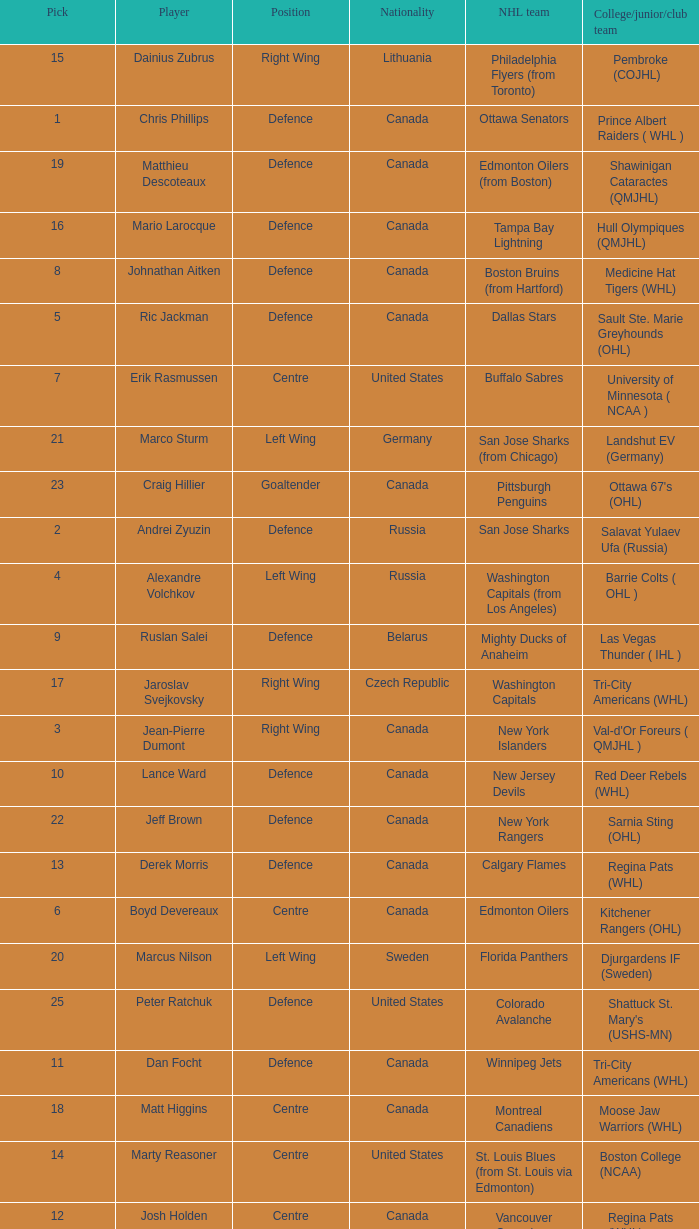Could you parse the entire table? {'header': ['Pick', 'Player', 'Position', 'Nationality', 'NHL team', 'College/junior/club team'], 'rows': [['15', 'Dainius Zubrus', 'Right Wing', 'Lithuania', 'Philadelphia Flyers (from Toronto)', 'Pembroke (COJHL)'], ['1', 'Chris Phillips', 'Defence', 'Canada', 'Ottawa Senators', 'Prince Albert Raiders ( WHL )'], ['19', 'Matthieu Descoteaux', 'Defence', 'Canada', 'Edmonton Oilers (from Boston)', 'Shawinigan Cataractes (QMJHL)'], ['16', 'Mario Larocque', 'Defence', 'Canada', 'Tampa Bay Lightning', 'Hull Olympiques (QMJHL)'], ['8', 'Johnathan Aitken', 'Defence', 'Canada', 'Boston Bruins (from Hartford)', 'Medicine Hat Tigers (WHL)'], ['5', 'Ric Jackman', 'Defence', 'Canada', 'Dallas Stars', 'Sault Ste. Marie Greyhounds (OHL)'], ['7', 'Erik Rasmussen', 'Centre', 'United States', 'Buffalo Sabres', 'University of Minnesota ( NCAA )'], ['21', 'Marco Sturm', 'Left Wing', 'Germany', 'San Jose Sharks (from Chicago)', 'Landshut EV (Germany)'], ['23', 'Craig Hillier', 'Goaltender', 'Canada', 'Pittsburgh Penguins', "Ottawa 67's (OHL)"], ['2', 'Andrei Zyuzin', 'Defence', 'Russia', 'San Jose Sharks', 'Salavat Yulaev Ufa (Russia)'], ['4', 'Alexandre Volchkov', 'Left Wing', 'Russia', 'Washington Capitals (from Los Angeles)', 'Barrie Colts ( OHL )'], ['9', 'Ruslan Salei', 'Defence', 'Belarus', 'Mighty Ducks of Anaheim', 'Las Vegas Thunder ( IHL )'], ['17', 'Jaroslav Svejkovsky', 'Right Wing', 'Czech Republic', 'Washington Capitals', 'Tri-City Americans (WHL)'], ['3', 'Jean-Pierre Dumont', 'Right Wing', 'Canada', 'New York Islanders', "Val-d'Or Foreurs ( QMJHL )"], ['10', 'Lance Ward', 'Defence', 'Canada', 'New Jersey Devils', 'Red Deer Rebels (WHL)'], ['22', 'Jeff Brown', 'Defence', 'Canada', 'New York Rangers', 'Sarnia Sting (OHL)'], ['13', 'Derek Morris', 'Defence', 'Canada', 'Calgary Flames', 'Regina Pats (WHL)'], ['6', 'Boyd Devereaux', 'Centre', 'Canada', 'Edmonton Oilers', 'Kitchener Rangers (OHL)'], ['20', 'Marcus Nilson', 'Left Wing', 'Sweden', 'Florida Panthers', 'Djurgardens IF (Sweden)'], ['25', 'Peter Ratchuk', 'Defence', 'United States', 'Colorado Avalanche', "Shattuck St. Mary's (USHS-MN)"], ['11', 'Dan Focht', 'Defence', 'Canada', 'Winnipeg Jets', 'Tri-City Americans (WHL)'], ['18', 'Matt Higgins', 'Centre', 'Canada', 'Montreal Canadiens', 'Moose Jaw Warriors (WHL)'], ['14', 'Marty Reasoner', 'Centre', 'United States', 'St. Louis Blues (from St. Louis via Edmonton)', 'Boston College (NCAA)'], ['12', 'Josh Holden', 'Centre', 'Canada', 'Vancouver Canucks', 'Regina Pats (WHL)']]} How many positions does the draft pick whose nationality is Czech Republic play? 1.0. 